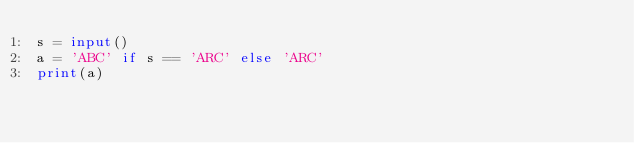<code> <loc_0><loc_0><loc_500><loc_500><_Python_>s = input()
a = 'ABC' if s == 'ARC' else 'ARC'
print(a)</code> 